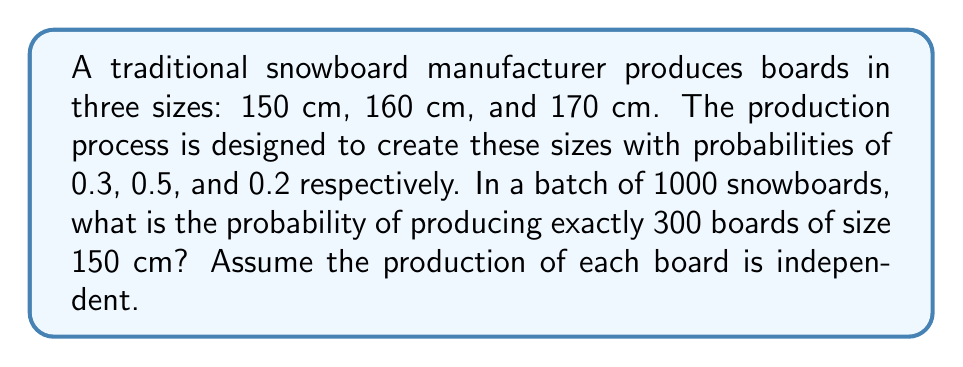What is the answer to this math problem? To solve this problem, we can use the binomial probability distribution:

1) The probability mass function for a binomial distribution is:

   $$P(X = k) = \binom{n}{k} p^k (1-p)^{n-k}$$

   Where:
   $n$ = number of trials
   $k$ = number of successes
   $p$ = probability of success on each trial

2) In this case:
   $n = 1000$ (total boards in the batch)
   $k = 300$ (desired number of 150 cm boards)
   $p = 0.3$ (probability of producing a 150 cm board)

3) Substituting these values:

   $$P(X = 300) = \binom{1000}{300} (0.3)^{300} (1-0.3)^{1000-300}$$

4) Simplify:

   $$P(X = 300) = \binom{1000}{300} (0.3)^{300} (0.7)^{700}$$

5) Calculate the binomial coefficient:

   $$\binom{1000}{300} = \frac{1000!}{300!(1000-300)!} = \frac{1000!}{300!700!}$$

6) Use a calculator or computer to evaluate this expression:

   $$P(X = 300) \approx 0.0248$$

Thus, the probability of producing exactly 300 boards of size 150 cm in a batch of 1000 is approximately 0.0248 or 2.48%.
Answer: 0.0248 